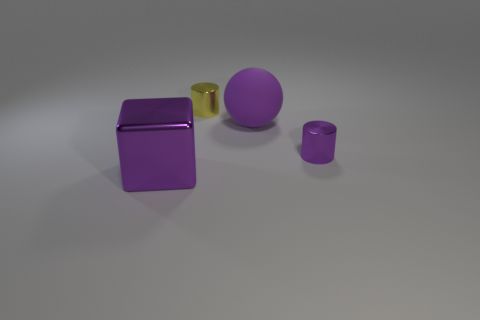Subtract 1 cylinders. How many cylinders are left? 1 Add 1 yellow things. How many objects exist? 5 Subtract 0 yellow blocks. How many objects are left? 4 Subtract all red cylinders. Subtract all green spheres. How many cylinders are left? 2 Subtract all purple cylinders. How many red balls are left? 0 Subtract all small yellow things. Subtract all purple metal objects. How many objects are left? 1 Add 3 large metal objects. How many large metal objects are left? 4 Add 2 cylinders. How many cylinders exist? 4 